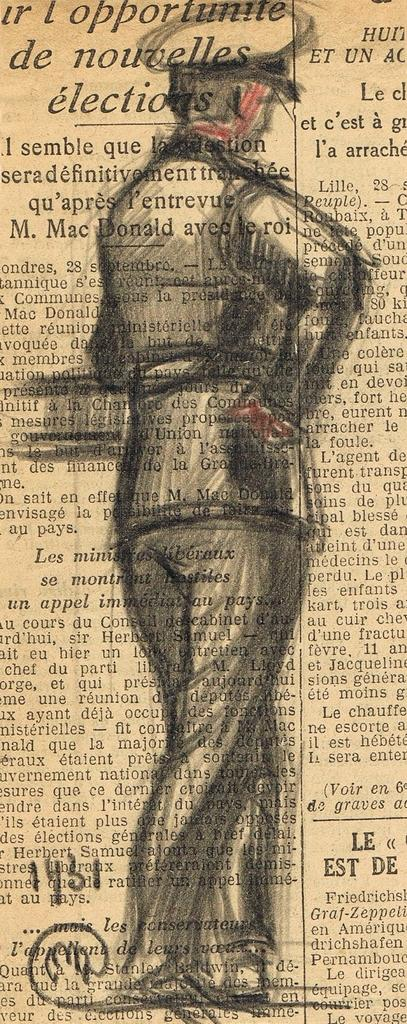What is the main object in the image? There is a newspaper in the image. What can be found on the newspaper? The newspaper has printed text. Is there any image or illustration on the newspaper? Yes, there is an art of a person wearing a uniform and a cap on the newspaper. How many houses are visible in the image? There are no houses visible in the image; it only features a newspaper with printed text and an illustration. Can you tell me how many pockets are on the person's uniform in the image? There is no person present in the image, only an illustration of a person wearing a uniform and a cap. --- Facts: 1. There is a car in the image. 2. The car is red. 3. The car has four wheels. 4. There is a person sitting in the driver's seat. 5. The person is wearing sunglasses. Absurd Topics: bird, ocean, dance Conversation: What is the main subject of the image? The main subject of the image is a car. What color is the car? The car is red. How many wheels does the car have? The car has four wheels. Is there anyone inside the car? Yes, there is a person sitting in the driver's seat. What can be seen on the person's face? The person is wearing sunglasses. Reasoning: Let's think step by step in order to produce the conversation. We start by identifying the main subject of the image, which is the car. Then, we describe the car's color and the number of wheels it has. Next, we mention the presence of a person inside the car and describe their appearance, specifically the sunglasses they are wearing. Absurd Question/Answer: Can you tell me how many birds are flying over the ocean in the image? There are no birds or ocean visible in the image; it only features a red car with a person wearing sunglasses. Is there any dancing happening in the image? There is no dancing visible in the image; it only features a red car with a person wearing sunglasses. 